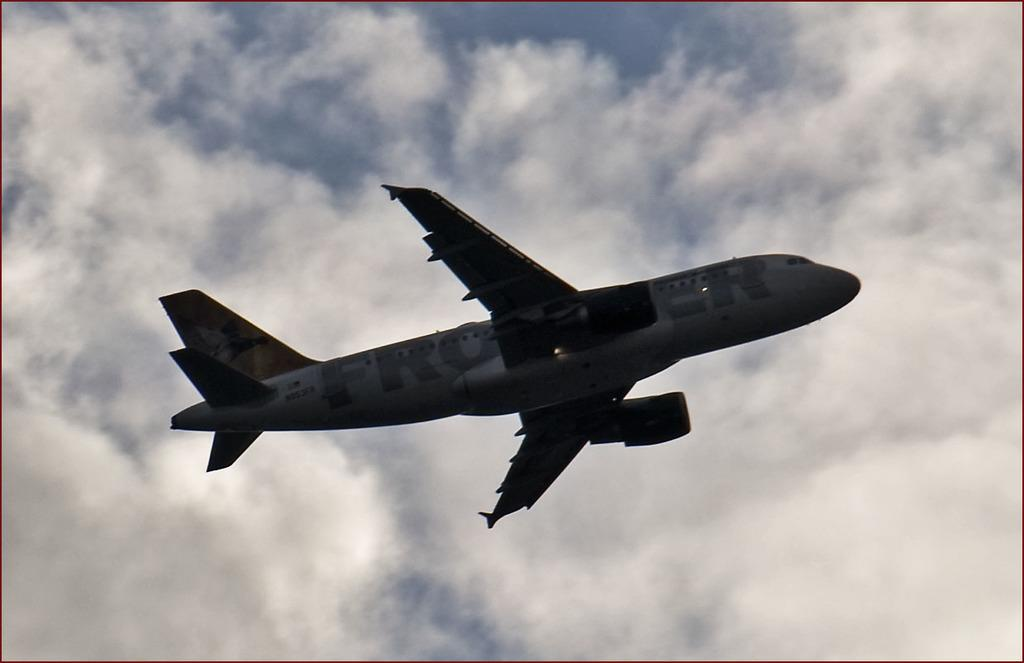<image>
Create a compact narrative representing the image presented. Froer Airplane in the sky with a american flag labeled on it. 